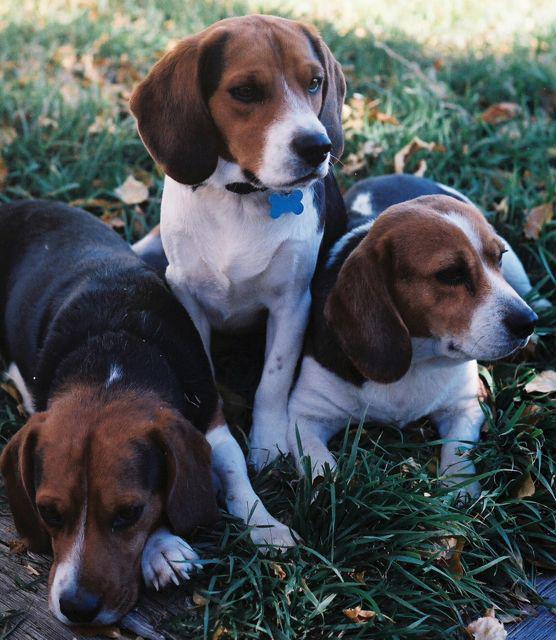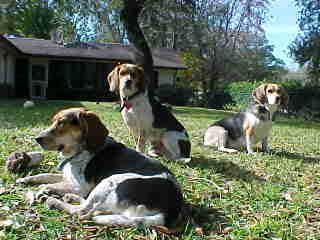The first image is the image on the left, the second image is the image on the right. Assess this claim about the two images: "There are three dogs in the grass in at least one of the images.". Correct or not? Answer yes or no. Yes. The first image is the image on the left, the second image is the image on the right. For the images shown, is this caption "One image shows three hounds posed on a rail, with the one in the middle taller than the others, and the other image shows three side-by-side dogs with the leftmost looking taller." true? Answer yes or no. No. 